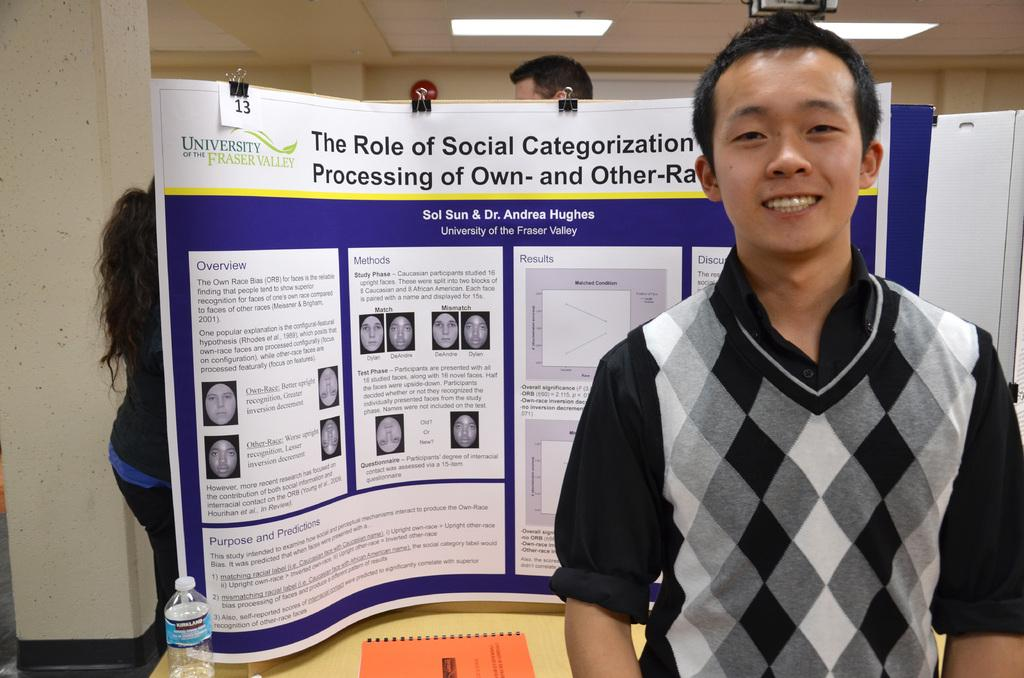<image>
Relay a brief, clear account of the picture shown. Young man standing in front of his Role of Social Categorization project. 